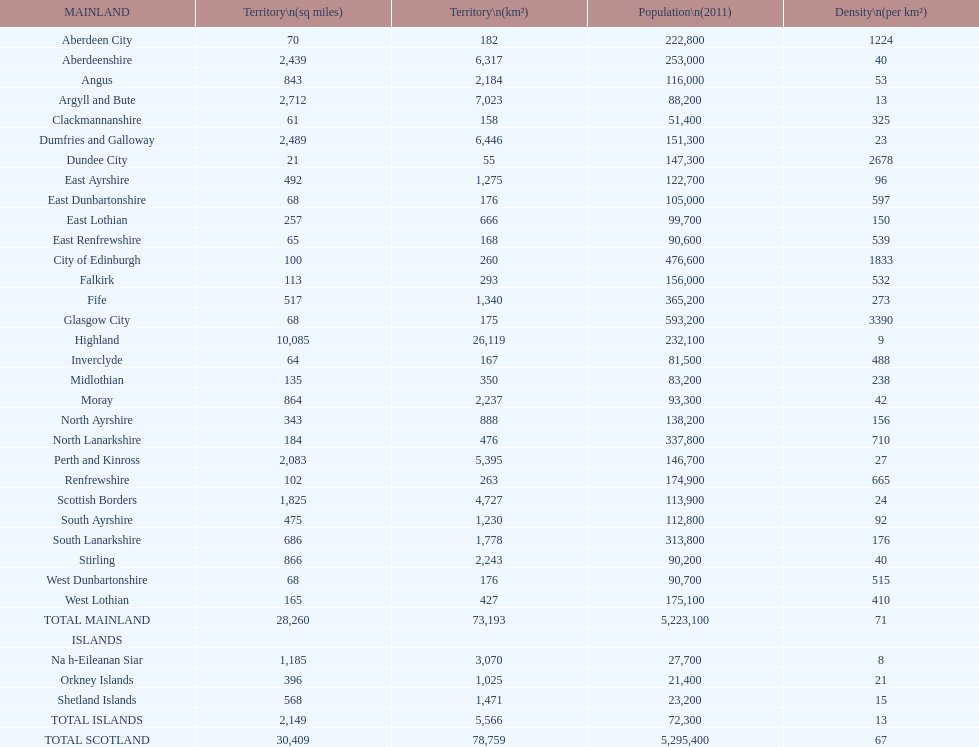What is the number of people living in angus in 2011? 116,000. 